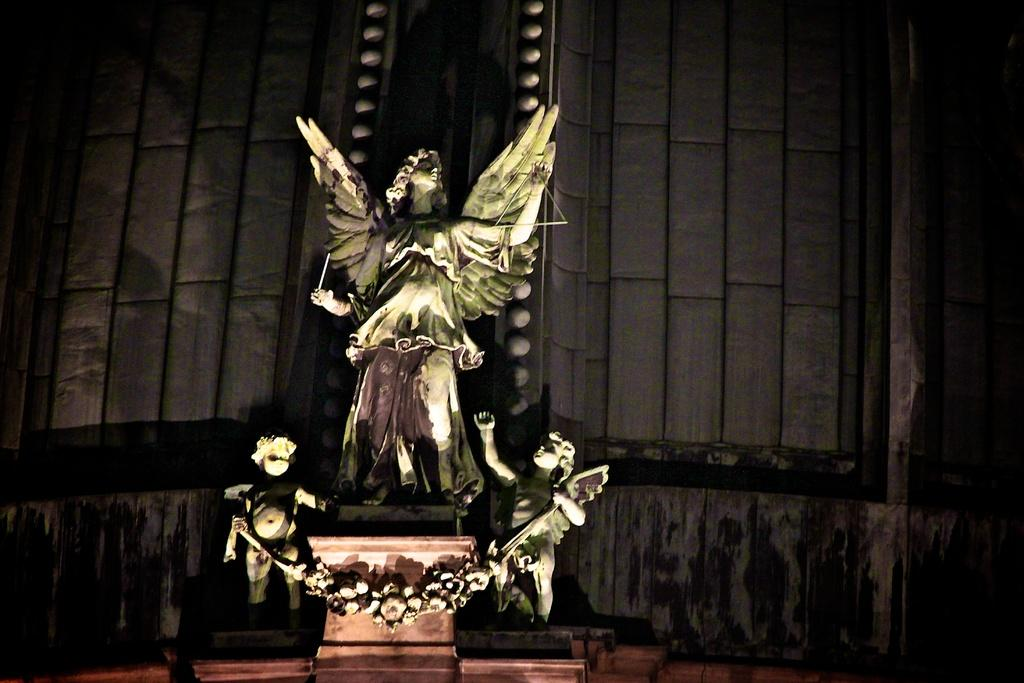What is the main subject in the middle of the image? There is a statue in the middle of the image. What color is the background of the image? The background of the image is black. How many boats are visible in the image? There are no boats present in the image. What type of war is depicted in the image? There is no depiction of war in the image; it features a statue with a black background. 